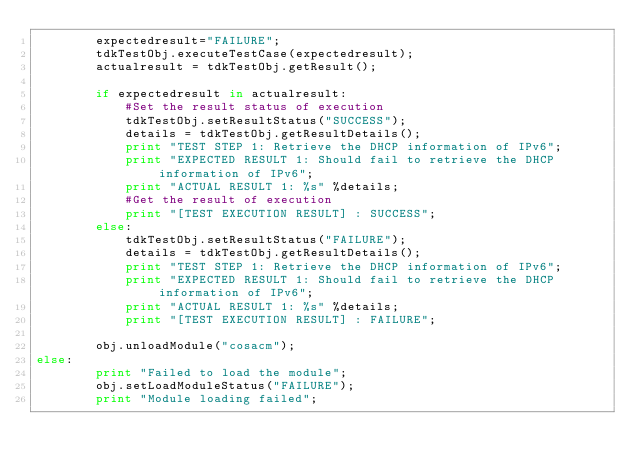Convert code to text. <code><loc_0><loc_0><loc_500><loc_500><_Python_>        expectedresult="FAILURE";
        tdkTestObj.executeTestCase(expectedresult);
        actualresult = tdkTestObj.getResult();

        if expectedresult in actualresult:
            #Set the result status of execution
            tdkTestObj.setResultStatus("SUCCESS");
            details = tdkTestObj.getResultDetails();
            print "TEST STEP 1: Retrieve the DHCP information of IPv6";
            print "EXPECTED RESULT 1: Should fail to retrieve the DHCP information of IPv6";
            print "ACTUAL RESULT 1: %s" %details;
            #Get the result of execution
            print "[TEST EXECUTION RESULT] : SUCCESS"; 
        else:
            tdkTestObj.setResultStatus("FAILURE");
            details = tdkTestObj.getResultDetails();
            print "TEST STEP 1: Retrieve the DHCP information of IPv6";
            print "EXPECTED RESULT 1: Should fail to retrieve the DHCP information of IPv6";
            print "ACTUAL RESULT 1: %s" %details;
            print "[TEST EXECUTION RESULT] : FAILURE";              
            
        obj.unloadModule("cosacm");
else:
        print "Failed to load the module";
        obj.setLoadModuleStatus("FAILURE");
        print "Module loading failed";
</code> 